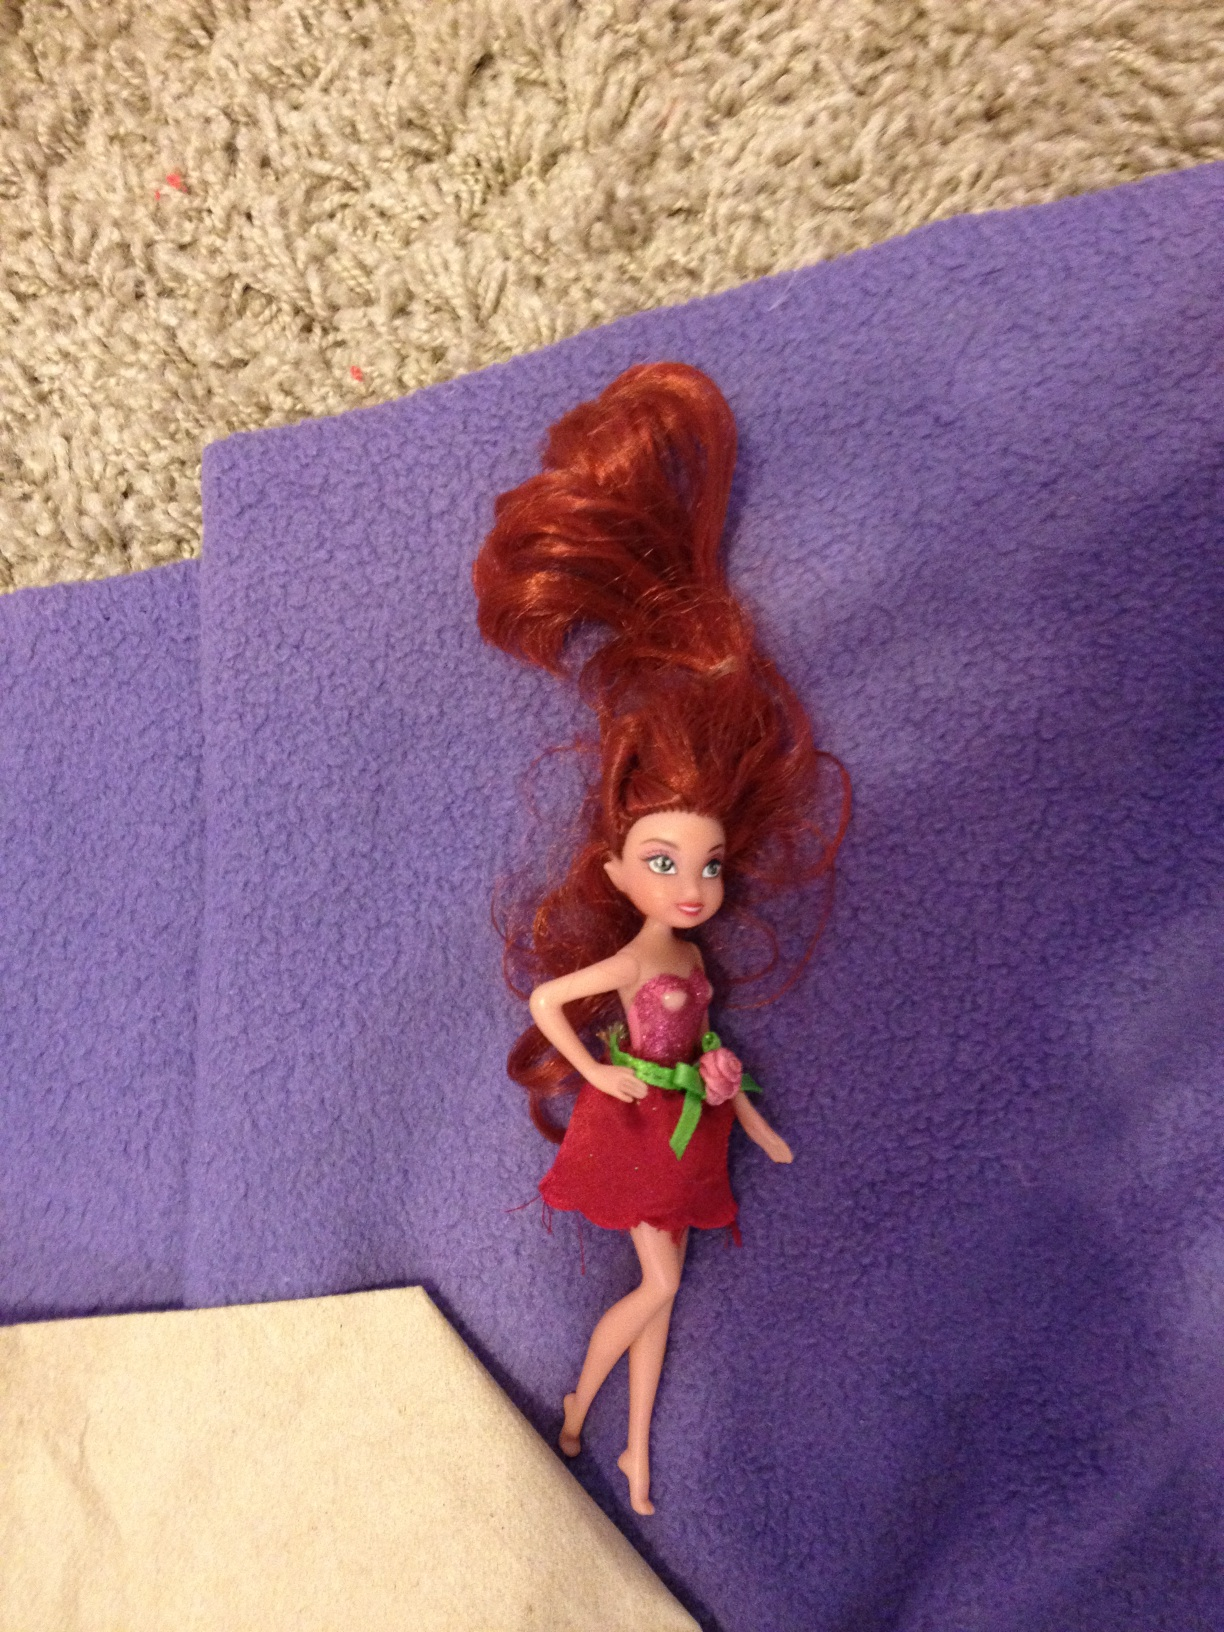What might be the context or story behind this image? It could be an image taken after a child's playtime, capturing a moment of pure, imaginative play. The positioning of the doll could suggest it's resting after a 'busy day', possibly a scene created by a young storyteller during their play. Is there anything else of interest in the image? Aside from the doll itself, the contrast between the textured carpet and the smooth purple surface may draw one's attention. This juxtaposition could be seen as a portrayal of the different environments and materials that come into play in a child's world. 